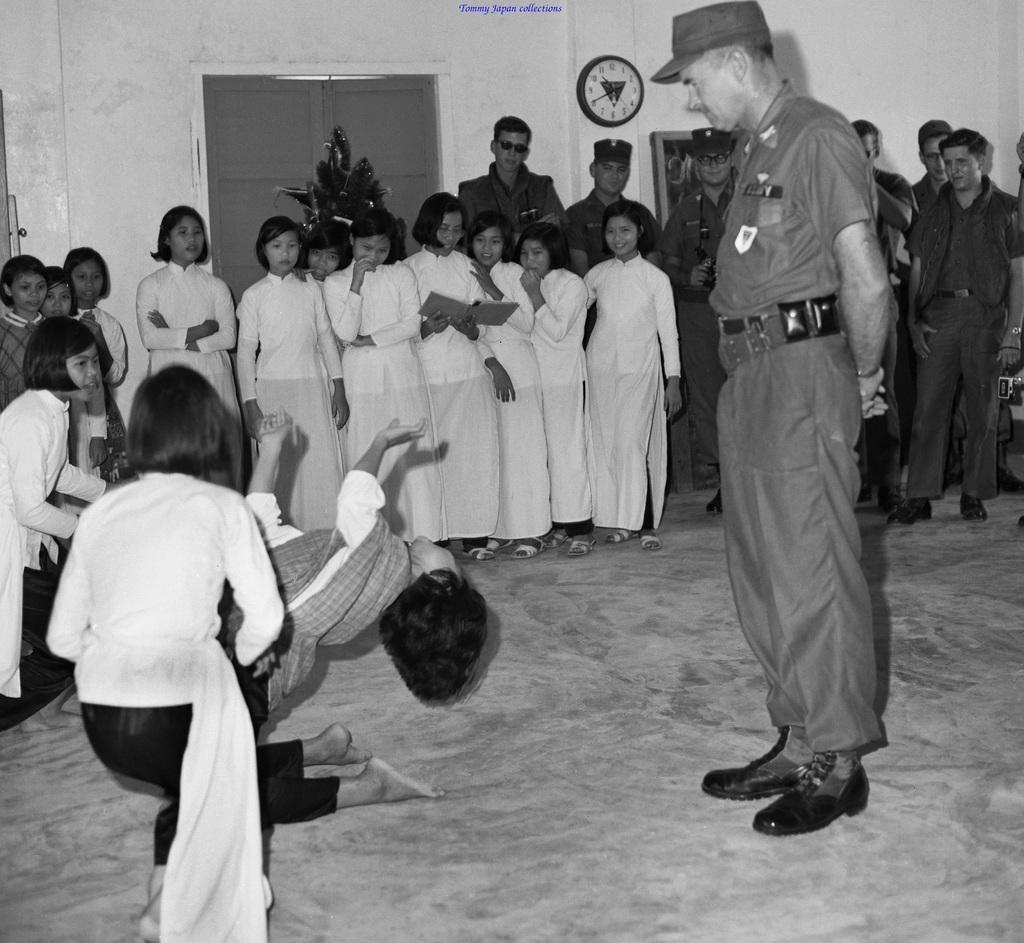Please provide a concise description of this image. In this picture we observe few girls are who are dressed in white are standing in the background and we observe a girl who is bending in reverse direction towards a man standing behind her. 